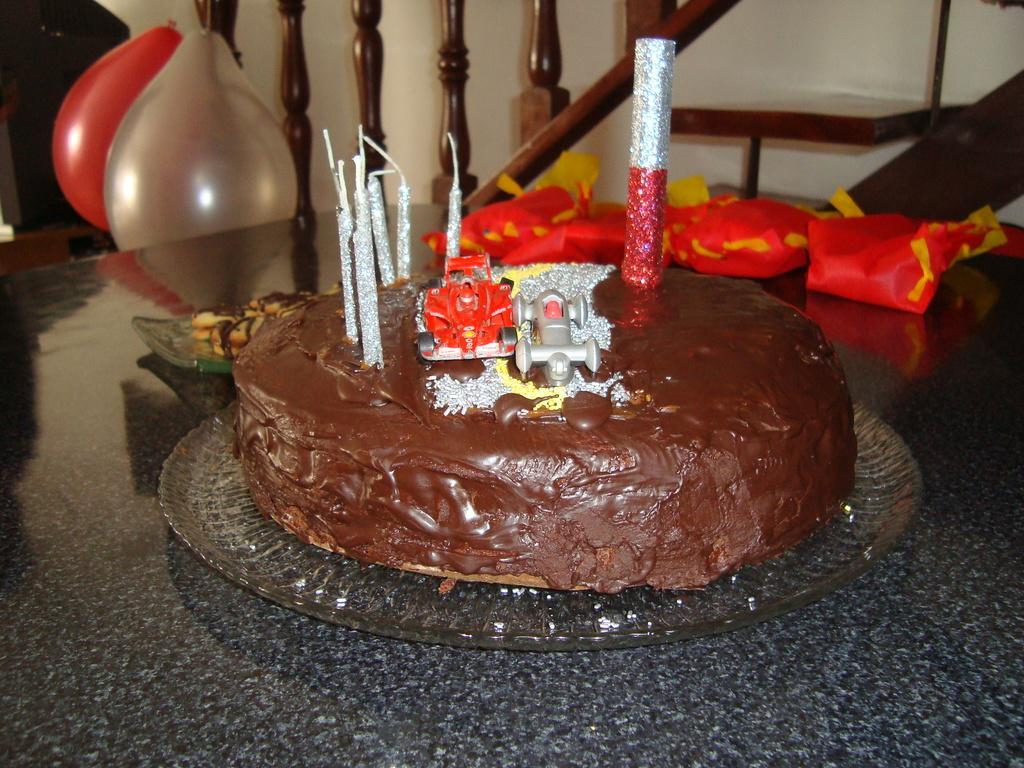Please provide a concise description of this image. In this image there is a table and we can see a cake, trays, packets and some food placed on the table. In the background there are balloons and we can see stairs. There is a wall. 